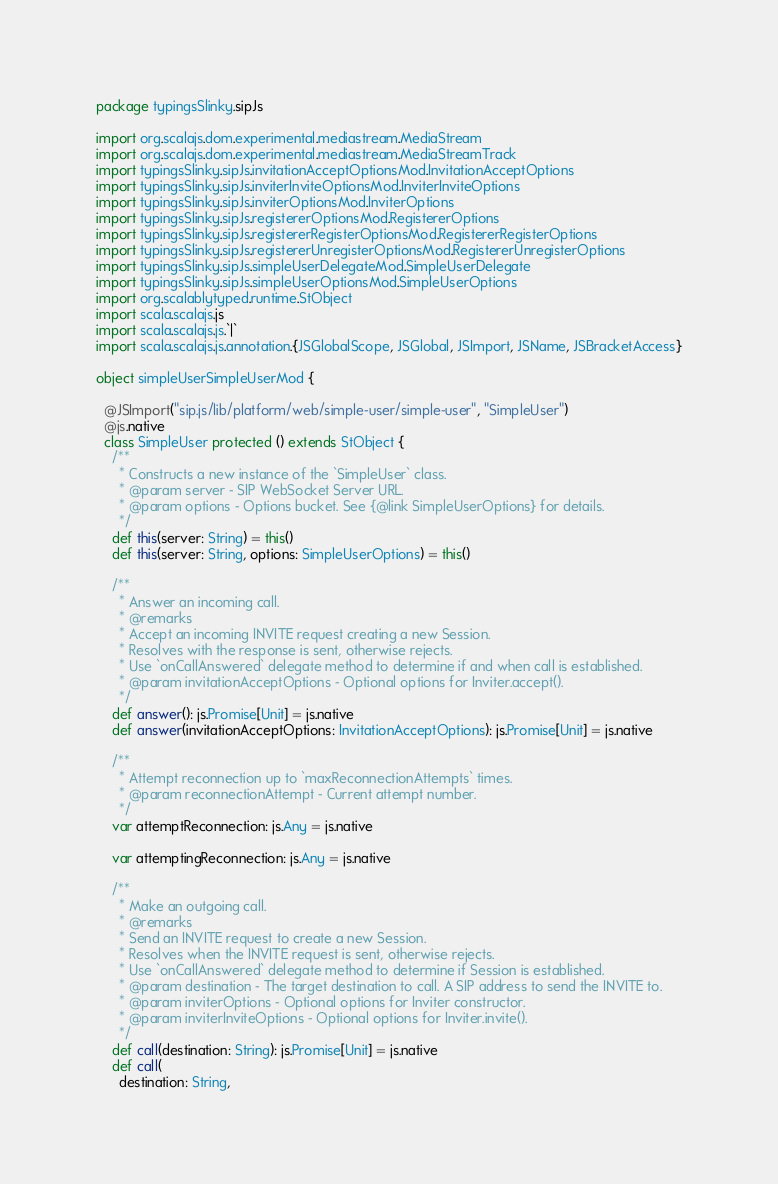<code> <loc_0><loc_0><loc_500><loc_500><_Scala_>package typingsSlinky.sipJs

import org.scalajs.dom.experimental.mediastream.MediaStream
import org.scalajs.dom.experimental.mediastream.MediaStreamTrack
import typingsSlinky.sipJs.invitationAcceptOptionsMod.InvitationAcceptOptions
import typingsSlinky.sipJs.inviterInviteOptionsMod.InviterInviteOptions
import typingsSlinky.sipJs.inviterOptionsMod.InviterOptions
import typingsSlinky.sipJs.registererOptionsMod.RegistererOptions
import typingsSlinky.sipJs.registererRegisterOptionsMod.RegistererRegisterOptions
import typingsSlinky.sipJs.registererUnregisterOptionsMod.RegistererUnregisterOptions
import typingsSlinky.sipJs.simpleUserDelegateMod.SimpleUserDelegate
import typingsSlinky.sipJs.simpleUserOptionsMod.SimpleUserOptions
import org.scalablytyped.runtime.StObject
import scala.scalajs.js
import scala.scalajs.js.`|`
import scala.scalajs.js.annotation.{JSGlobalScope, JSGlobal, JSImport, JSName, JSBracketAccess}

object simpleUserSimpleUserMod {
  
  @JSImport("sip.js/lib/platform/web/simple-user/simple-user", "SimpleUser")
  @js.native
  class SimpleUser protected () extends StObject {
    /**
      * Constructs a new instance of the `SimpleUser` class.
      * @param server - SIP WebSocket Server URL.
      * @param options - Options bucket. See {@link SimpleUserOptions} for details.
      */
    def this(server: String) = this()
    def this(server: String, options: SimpleUserOptions) = this()
    
    /**
      * Answer an incoming call.
      * @remarks
      * Accept an incoming INVITE request creating a new Session.
      * Resolves with the response is sent, otherwise rejects.
      * Use `onCallAnswered` delegate method to determine if and when call is established.
      * @param invitationAcceptOptions - Optional options for Inviter.accept().
      */
    def answer(): js.Promise[Unit] = js.native
    def answer(invitationAcceptOptions: InvitationAcceptOptions): js.Promise[Unit] = js.native
    
    /**
      * Attempt reconnection up to `maxReconnectionAttempts` times.
      * @param reconnectionAttempt - Current attempt number.
      */
    var attemptReconnection: js.Any = js.native
    
    var attemptingReconnection: js.Any = js.native
    
    /**
      * Make an outgoing call.
      * @remarks
      * Send an INVITE request to create a new Session.
      * Resolves when the INVITE request is sent, otherwise rejects.
      * Use `onCallAnswered` delegate method to determine if Session is established.
      * @param destination - The target destination to call. A SIP address to send the INVITE to.
      * @param inviterOptions - Optional options for Inviter constructor.
      * @param inviterInviteOptions - Optional options for Inviter.invite().
      */
    def call(destination: String): js.Promise[Unit] = js.native
    def call(
      destination: String,</code> 